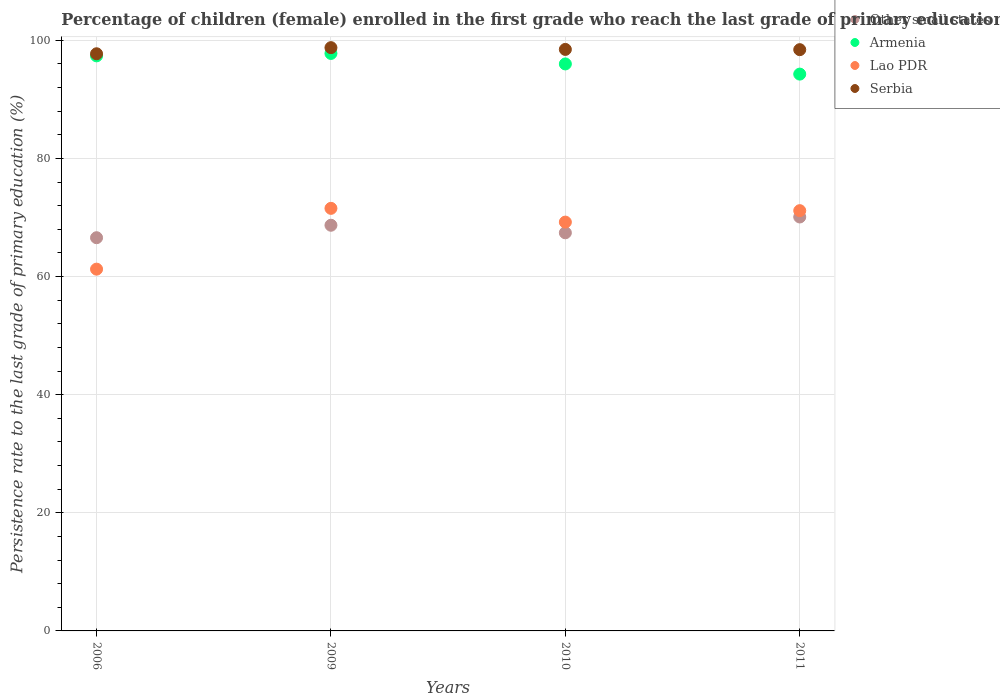What is the persistence rate of children in Lao PDR in 2010?
Ensure brevity in your answer.  69.21. Across all years, what is the maximum persistence rate of children in Serbia?
Offer a terse response. 98.75. Across all years, what is the minimum persistence rate of children in Armenia?
Ensure brevity in your answer.  94.27. In which year was the persistence rate of children in Other small states maximum?
Offer a terse response. 2011. What is the total persistence rate of children in Other small states in the graph?
Provide a short and direct response. 272.73. What is the difference between the persistence rate of children in Armenia in 2006 and that in 2009?
Offer a very short reply. -0.41. What is the difference between the persistence rate of children in Other small states in 2006 and the persistence rate of children in Armenia in 2011?
Your answer should be compact. -27.7. What is the average persistence rate of children in Lao PDR per year?
Your answer should be compact. 68.29. In the year 2009, what is the difference between the persistence rate of children in Serbia and persistence rate of children in Lao PDR?
Make the answer very short. 27.21. What is the ratio of the persistence rate of children in Lao PDR in 2006 to that in 2009?
Make the answer very short. 0.86. What is the difference between the highest and the second highest persistence rate of children in Armenia?
Your response must be concise. 0.41. What is the difference between the highest and the lowest persistence rate of children in Serbia?
Keep it short and to the point. 1.04. In how many years, is the persistence rate of children in Armenia greater than the average persistence rate of children in Armenia taken over all years?
Offer a terse response. 2. Does the persistence rate of children in Other small states monotonically increase over the years?
Offer a terse response. No. Is the persistence rate of children in Armenia strictly greater than the persistence rate of children in Lao PDR over the years?
Your answer should be compact. Yes. Is the persistence rate of children in Lao PDR strictly less than the persistence rate of children in Armenia over the years?
Offer a very short reply. Yes. What is the difference between two consecutive major ticks on the Y-axis?
Keep it short and to the point. 20. Are the values on the major ticks of Y-axis written in scientific E-notation?
Give a very brief answer. No. Does the graph contain any zero values?
Your response must be concise. No. Does the graph contain grids?
Ensure brevity in your answer.  Yes. Where does the legend appear in the graph?
Ensure brevity in your answer.  Top right. How are the legend labels stacked?
Keep it short and to the point. Vertical. What is the title of the graph?
Your answer should be compact. Percentage of children (female) enrolled in the first grade who reach the last grade of primary education. Does "Senegal" appear as one of the legend labels in the graph?
Your response must be concise. No. What is the label or title of the X-axis?
Give a very brief answer. Years. What is the label or title of the Y-axis?
Offer a very short reply. Persistence rate to the last grade of primary education (%). What is the Persistence rate to the last grade of primary education (%) in Other small states in 2006?
Ensure brevity in your answer.  66.57. What is the Persistence rate to the last grade of primary education (%) in Armenia in 2006?
Your answer should be compact. 97.36. What is the Persistence rate to the last grade of primary education (%) in Lao PDR in 2006?
Provide a succinct answer. 61.25. What is the Persistence rate to the last grade of primary education (%) in Serbia in 2006?
Offer a very short reply. 97.71. What is the Persistence rate to the last grade of primary education (%) in Other small states in 2009?
Make the answer very short. 68.68. What is the Persistence rate to the last grade of primary education (%) in Armenia in 2009?
Give a very brief answer. 97.76. What is the Persistence rate to the last grade of primary education (%) in Lao PDR in 2009?
Offer a very short reply. 71.54. What is the Persistence rate to the last grade of primary education (%) of Serbia in 2009?
Ensure brevity in your answer.  98.75. What is the Persistence rate to the last grade of primary education (%) of Other small states in 2010?
Offer a terse response. 67.4. What is the Persistence rate to the last grade of primary education (%) of Armenia in 2010?
Ensure brevity in your answer.  95.99. What is the Persistence rate to the last grade of primary education (%) of Lao PDR in 2010?
Your response must be concise. 69.21. What is the Persistence rate to the last grade of primary education (%) of Serbia in 2010?
Make the answer very short. 98.45. What is the Persistence rate to the last grade of primary education (%) of Other small states in 2011?
Ensure brevity in your answer.  70.08. What is the Persistence rate to the last grade of primary education (%) of Armenia in 2011?
Provide a short and direct response. 94.27. What is the Persistence rate to the last grade of primary education (%) in Lao PDR in 2011?
Your answer should be compact. 71.15. What is the Persistence rate to the last grade of primary education (%) of Serbia in 2011?
Offer a terse response. 98.41. Across all years, what is the maximum Persistence rate to the last grade of primary education (%) in Other small states?
Provide a succinct answer. 70.08. Across all years, what is the maximum Persistence rate to the last grade of primary education (%) of Armenia?
Your answer should be very brief. 97.76. Across all years, what is the maximum Persistence rate to the last grade of primary education (%) of Lao PDR?
Offer a very short reply. 71.54. Across all years, what is the maximum Persistence rate to the last grade of primary education (%) of Serbia?
Offer a very short reply. 98.75. Across all years, what is the minimum Persistence rate to the last grade of primary education (%) in Other small states?
Offer a terse response. 66.57. Across all years, what is the minimum Persistence rate to the last grade of primary education (%) in Armenia?
Provide a succinct answer. 94.27. Across all years, what is the minimum Persistence rate to the last grade of primary education (%) of Lao PDR?
Make the answer very short. 61.25. Across all years, what is the minimum Persistence rate to the last grade of primary education (%) of Serbia?
Your response must be concise. 97.71. What is the total Persistence rate to the last grade of primary education (%) in Other small states in the graph?
Keep it short and to the point. 272.73. What is the total Persistence rate to the last grade of primary education (%) in Armenia in the graph?
Provide a short and direct response. 385.37. What is the total Persistence rate to the last grade of primary education (%) in Lao PDR in the graph?
Your response must be concise. 273.15. What is the total Persistence rate to the last grade of primary education (%) of Serbia in the graph?
Ensure brevity in your answer.  393.31. What is the difference between the Persistence rate to the last grade of primary education (%) in Other small states in 2006 and that in 2009?
Make the answer very short. -2.11. What is the difference between the Persistence rate to the last grade of primary education (%) in Armenia in 2006 and that in 2009?
Your answer should be compact. -0.41. What is the difference between the Persistence rate to the last grade of primary education (%) in Lao PDR in 2006 and that in 2009?
Make the answer very short. -10.29. What is the difference between the Persistence rate to the last grade of primary education (%) in Serbia in 2006 and that in 2009?
Provide a short and direct response. -1.04. What is the difference between the Persistence rate to the last grade of primary education (%) of Other small states in 2006 and that in 2010?
Offer a very short reply. -0.83. What is the difference between the Persistence rate to the last grade of primary education (%) in Armenia in 2006 and that in 2010?
Keep it short and to the point. 1.37. What is the difference between the Persistence rate to the last grade of primary education (%) of Lao PDR in 2006 and that in 2010?
Provide a succinct answer. -7.97. What is the difference between the Persistence rate to the last grade of primary education (%) of Serbia in 2006 and that in 2010?
Keep it short and to the point. -0.74. What is the difference between the Persistence rate to the last grade of primary education (%) in Other small states in 2006 and that in 2011?
Ensure brevity in your answer.  -3.51. What is the difference between the Persistence rate to the last grade of primary education (%) of Armenia in 2006 and that in 2011?
Keep it short and to the point. 3.09. What is the difference between the Persistence rate to the last grade of primary education (%) in Lao PDR in 2006 and that in 2011?
Give a very brief answer. -9.9. What is the difference between the Persistence rate to the last grade of primary education (%) of Serbia in 2006 and that in 2011?
Your response must be concise. -0.7. What is the difference between the Persistence rate to the last grade of primary education (%) of Other small states in 2009 and that in 2010?
Your answer should be compact. 1.28. What is the difference between the Persistence rate to the last grade of primary education (%) of Armenia in 2009 and that in 2010?
Your answer should be very brief. 1.77. What is the difference between the Persistence rate to the last grade of primary education (%) of Lao PDR in 2009 and that in 2010?
Your answer should be compact. 2.33. What is the difference between the Persistence rate to the last grade of primary education (%) in Serbia in 2009 and that in 2010?
Ensure brevity in your answer.  0.3. What is the difference between the Persistence rate to the last grade of primary education (%) of Other small states in 2009 and that in 2011?
Your answer should be compact. -1.4. What is the difference between the Persistence rate to the last grade of primary education (%) of Armenia in 2009 and that in 2011?
Offer a very short reply. 3.5. What is the difference between the Persistence rate to the last grade of primary education (%) of Lao PDR in 2009 and that in 2011?
Offer a very short reply. 0.39. What is the difference between the Persistence rate to the last grade of primary education (%) of Serbia in 2009 and that in 2011?
Make the answer very short. 0.34. What is the difference between the Persistence rate to the last grade of primary education (%) of Other small states in 2010 and that in 2011?
Offer a very short reply. -2.68. What is the difference between the Persistence rate to the last grade of primary education (%) in Armenia in 2010 and that in 2011?
Your answer should be compact. 1.72. What is the difference between the Persistence rate to the last grade of primary education (%) of Lao PDR in 2010 and that in 2011?
Your response must be concise. -1.94. What is the difference between the Persistence rate to the last grade of primary education (%) in Serbia in 2010 and that in 2011?
Make the answer very short. 0.04. What is the difference between the Persistence rate to the last grade of primary education (%) in Other small states in 2006 and the Persistence rate to the last grade of primary education (%) in Armenia in 2009?
Give a very brief answer. -31.19. What is the difference between the Persistence rate to the last grade of primary education (%) in Other small states in 2006 and the Persistence rate to the last grade of primary education (%) in Lao PDR in 2009?
Provide a succinct answer. -4.97. What is the difference between the Persistence rate to the last grade of primary education (%) in Other small states in 2006 and the Persistence rate to the last grade of primary education (%) in Serbia in 2009?
Ensure brevity in your answer.  -32.18. What is the difference between the Persistence rate to the last grade of primary education (%) of Armenia in 2006 and the Persistence rate to the last grade of primary education (%) of Lao PDR in 2009?
Ensure brevity in your answer.  25.82. What is the difference between the Persistence rate to the last grade of primary education (%) in Armenia in 2006 and the Persistence rate to the last grade of primary education (%) in Serbia in 2009?
Offer a very short reply. -1.39. What is the difference between the Persistence rate to the last grade of primary education (%) of Lao PDR in 2006 and the Persistence rate to the last grade of primary education (%) of Serbia in 2009?
Keep it short and to the point. -37.5. What is the difference between the Persistence rate to the last grade of primary education (%) of Other small states in 2006 and the Persistence rate to the last grade of primary education (%) of Armenia in 2010?
Ensure brevity in your answer.  -29.42. What is the difference between the Persistence rate to the last grade of primary education (%) in Other small states in 2006 and the Persistence rate to the last grade of primary education (%) in Lao PDR in 2010?
Provide a short and direct response. -2.64. What is the difference between the Persistence rate to the last grade of primary education (%) in Other small states in 2006 and the Persistence rate to the last grade of primary education (%) in Serbia in 2010?
Offer a terse response. -31.88. What is the difference between the Persistence rate to the last grade of primary education (%) in Armenia in 2006 and the Persistence rate to the last grade of primary education (%) in Lao PDR in 2010?
Make the answer very short. 28.14. What is the difference between the Persistence rate to the last grade of primary education (%) of Armenia in 2006 and the Persistence rate to the last grade of primary education (%) of Serbia in 2010?
Provide a succinct answer. -1.09. What is the difference between the Persistence rate to the last grade of primary education (%) in Lao PDR in 2006 and the Persistence rate to the last grade of primary education (%) in Serbia in 2010?
Offer a terse response. -37.2. What is the difference between the Persistence rate to the last grade of primary education (%) of Other small states in 2006 and the Persistence rate to the last grade of primary education (%) of Armenia in 2011?
Keep it short and to the point. -27.7. What is the difference between the Persistence rate to the last grade of primary education (%) in Other small states in 2006 and the Persistence rate to the last grade of primary education (%) in Lao PDR in 2011?
Your response must be concise. -4.58. What is the difference between the Persistence rate to the last grade of primary education (%) of Other small states in 2006 and the Persistence rate to the last grade of primary education (%) of Serbia in 2011?
Offer a terse response. -31.84. What is the difference between the Persistence rate to the last grade of primary education (%) of Armenia in 2006 and the Persistence rate to the last grade of primary education (%) of Lao PDR in 2011?
Make the answer very short. 26.21. What is the difference between the Persistence rate to the last grade of primary education (%) of Armenia in 2006 and the Persistence rate to the last grade of primary education (%) of Serbia in 2011?
Offer a terse response. -1.05. What is the difference between the Persistence rate to the last grade of primary education (%) of Lao PDR in 2006 and the Persistence rate to the last grade of primary education (%) of Serbia in 2011?
Your response must be concise. -37.16. What is the difference between the Persistence rate to the last grade of primary education (%) of Other small states in 2009 and the Persistence rate to the last grade of primary education (%) of Armenia in 2010?
Provide a succinct answer. -27.31. What is the difference between the Persistence rate to the last grade of primary education (%) in Other small states in 2009 and the Persistence rate to the last grade of primary education (%) in Lao PDR in 2010?
Make the answer very short. -0.53. What is the difference between the Persistence rate to the last grade of primary education (%) in Other small states in 2009 and the Persistence rate to the last grade of primary education (%) in Serbia in 2010?
Offer a terse response. -29.77. What is the difference between the Persistence rate to the last grade of primary education (%) in Armenia in 2009 and the Persistence rate to the last grade of primary education (%) in Lao PDR in 2010?
Your answer should be compact. 28.55. What is the difference between the Persistence rate to the last grade of primary education (%) in Armenia in 2009 and the Persistence rate to the last grade of primary education (%) in Serbia in 2010?
Offer a very short reply. -0.68. What is the difference between the Persistence rate to the last grade of primary education (%) in Lao PDR in 2009 and the Persistence rate to the last grade of primary education (%) in Serbia in 2010?
Offer a very short reply. -26.91. What is the difference between the Persistence rate to the last grade of primary education (%) in Other small states in 2009 and the Persistence rate to the last grade of primary education (%) in Armenia in 2011?
Your answer should be compact. -25.59. What is the difference between the Persistence rate to the last grade of primary education (%) in Other small states in 2009 and the Persistence rate to the last grade of primary education (%) in Lao PDR in 2011?
Your response must be concise. -2.47. What is the difference between the Persistence rate to the last grade of primary education (%) in Other small states in 2009 and the Persistence rate to the last grade of primary education (%) in Serbia in 2011?
Give a very brief answer. -29.73. What is the difference between the Persistence rate to the last grade of primary education (%) in Armenia in 2009 and the Persistence rate to the last grade of primary education (%) in Lao PDR in 2011?
Keep it short and to the point. 26.61. What is the difference between the Persistence rate to the last grade of primary education (%) of Armenia in 2009 and the Persistence rate to the last grade of primary education (%) of Serbia in 2011?
Keep it short and to the point. -0.64. What is the difference between the Persistence rate to the last grade of primary education (%) in Lao PDR in 2009 and the Persistence rate to the last grade of primary education (%) in Serbia in 2011?
Make the answer very short. -26.87. What is the difference between the Persistence rate to the last grade of primary education (%) of Other small states in 2010 and the Persistence rate to the last grade of primary education (%) of Armenia in 2011?
Give a very brief answer. -26.86. What is the difference between the Persistence rate to the last grade of primary education (%) of Other small states in 2010 and the Persistence rate to the last grade of primary education (%) of Lao PDR in 2011?
Make the answer very short. -3.75. What is the difference between the Persistence rate to the last grade of primary education (%) of Other small states in 2010 and the Persistence rate to the last grade of primary education (%) of Serbia in 2011?
Keep it short and to the point. -31. What is the difference between the Persistence rate to the last grade of primary education (%) of Armenia in 2010 and the Persistence rate to the last grade of primary education (%) of Lao PDR in 2011?
Make the answer very short. 24.84. What is the difference between the Persistence rate to the last grade of primary education (%) of Armenia in 2010 and the Persistence rate to the last grade of primary education (%) of Serbia in 2011?
Give a very brief answer. -2.42. What is the difference between the Persistence rate to the last grade of primary education (%) of Lao PDR in 2010 and the Persistence rate to the last grade of primary education (%) of Serbia in 2011?
Make the answer very short. -29.19. What is the average Persistence rate to the last grade of primary education (%) of Other small states per year?
Provide a succinct answer. 68.18. What is the average Persistence rate to the last grade of primary education (%) of Armenia per year?
Your answer should be very brief. 96.34. What is the average Persistence rate to the last grade of primary education (%) in Lao PDR per year?
Your response must be concise. 68.29. What is the average Persistence rate to the last grade of primary education (%) in Serbia per year?
Offer a very short reply. 98.33. In the year 2006, what is the difference between the Persistence rate to the last grade of primary education (%) of Other small states and Persistence rate to the last grade of primary education (%) of Armenia?
Your response must be concise. -30.79. In the year 2006, what is the difference between the Persistence rate to the last grade of primary education (%) of Other small states and Persistence rate to the last grade of primary education (%) of Lao PDR?
Make the answer very short. 5.32. In the year 2006, what is the difference between the Persistence rate to the last grade of primary education (%) of Other small states and Persistence rate to the last grade of primary education (%) of Serbia?
Your answer should be very brief. -31.14. In the year 2006, what is the difference between the Persistence rate to the last grade of primary education (%) in Armenia and Persistence rate to the last grade of primary education (%) in Lao PDR?
Provide a succinct answer. 36.11. In the year 2006, what is the difference between the Persistence rate to the last grade of primary education (%) in Armenia and Persistence rate to the last grade of primary education (%) in Serbia?
Provide a succinct answer. -0.35. In the year 2006, what is the difference between the Persistence rate to the last grade of primary education (%) of Lao PDR and Persistence rate to the last grade of primary education (%) of Serbia?
Ensure brevity in your answer.  -36.46. In the year 2009, what is the difference between the Persistence rate to the last grade of primary education (%) of Other small states and Persistence rate to the last grade of primary education (%) of Armenia?
Your answer should be very brief. -29.08. In the year 2009, what is the difference between the Persistence rate to the last grade of primary education (%) in Other small states and Persistence rate to the last grade of primary education (%) in Lao PDR?
Provide a short and direct response. -2.86. In the year 2009, what is the difference between the Persistence rate to the last grade of primary education (%) in Other small states and Persistence rate to the last grade of primary education (%) in Serbia?
Offer a very short reply. -30.07. In the year 2009, what is the difference between the Persistence rate to the last grade of primary education (%) of Armenia and Persistence rate to the last grade of primary education (%) of Lao PDR?
Offer a very short reply. 26.22. In the year 2009, what is the difference between the Persistence rate to the last grade of primary education (%) of Armenia and Persistence rate to the last grade of primary education (%) of Serbia?
Your answer should be very brief. -0.98. In the year 2009, what is the difference between the Persistence rate to the last grade of primary education (%) of Lao PDR and Persistence rate to the last grade of primary education (%) of Serbia?
Your response must be concise. -27.21. In the year 2010, what is the difference between the Persistence rate to the last grade of primary education (%) in Other small states and Persistence rate to the last grade of primary education (%) in Armenia?
Provide a succinct answer. -28.59. In the year 2010, what is the difference between the Persistence rate to the last grade of primary education (%) in Other small states and Persistence rate to the last grade of primary education (%) in Lao PDR?
Ensure brevity in your answer.  -1.81. In the year 2010, what is the difference between the Persistence rate to the last grade of primary education (%) of Other small states and Persistence rate to the last grade of primary education (%) of Serbia?
Provide a succinct answer. -31.05. In the year 2010, what is the difference between the Persistence rate to the last grade of primary education (%) in Armenia and Persistence rate to the last grade of primary education (%) in Lao PDR?
Make the answer very short. 26.78. In the year 2010, what is the difference between the Persistence rate to the last grade of primary education (%) in Armenia and Persistence rate to the last grade of primary education (%) in Serbia?
Ensure brevity in your answer.  -2.46. In the year 2010, what is the difference between the Persistence rate to the last grade of primary education (%) of Lao PDR and Persistence rate to the last grade of primary education (%) of Serbia?
Provide a short and direct response. -29.23. In the year 2011, what is the difference between the Persistence rate to the last grade of primary education (%) of Other small states and Persistence rate to the last grade of primary education (%) of Armenia?
Make the answer very short. -24.19. In the year 2011, what is the difference between the Persistence rate to the last grade of primary education (%) in Other small states and Persistence rate to the last grade of primary education (%) in Lao PDR?
Give a very brief answer. -1.07. In the year 2011, what is the difference between the Persistence rate to the last grade of primary education (%) of Other small states and Persistence rate to the last grade of primary education (%) of Serbia?
Your answer should be compact. -28.33. In the year 2011, what is the difference between the Persistence rate to the last grade of primary education (%) of Armenia and Persistence rate to the last grade of primary education (%) of Lao PDR?
Provide a short and direct response. 23.12. In the year 2011, what is the difference between the Persistence rate to the last grade of primary education (%) in Armenia and Persistence rate to the last grade of primary education (%) in Serbia?
Your response must be concise. -4.14. In the year 2011, what is the difference between the Persistence rate to the last grade of primary education (%) of Lao PDR and Persistence rate to the last grade of primary education (%) of Serbia?
Offer a terse response. -27.26. What is the ratio of the Persistence rate to the last grade of primary education (%) in Other small states in 2006 to that in 2009?
Offer a terse response. 0.97. What is the ratio of the Persistence rate to the last grade of primary education (%) in Lao PDR in 2006 to that in 2009?
Offer a terse response. 0.86. What is the ratio of the Persistence rate to the last grade of primary education (%) in Serbia in 2006 to that in 2009?
Provide a succinct answer. 0.99. What is the ratio of the Persistence rate to the last grade of primary education (%) in Other small states in 2006 to that in 2010?
Make the answer very short. 0.99. What is the ratio of the Persistence rate to the last grade of primary education (%) of Armenia in 2006 to that in 2010?
Your answer should be compact. 1.01. What is the ratio of the Persistence rate to the last grade of primary education (%) of Lao PDR in 2006 to that in 2010?
Offer a very short reply. 0.88. What is the ratio of the Persistence rate to the last grade of primary education (%) in Other small states in 2006 to that in 2011?
Keep it short and to the point. 0.95. What is the ratio of the Persistence rate to the last grade of primary education (%) of Armenia in 2006 to that in 2011?
Offer a terse response. 1.03. What is the ratio of the Persistence rate to the last grade of primary education (%) in Lao PDR in 2006 to that in 2011?
Ensure brevity in your answer.  0.86. What is the ratio of the Persistence rate to the last grade of primary education (%) of Serbia in 2006 to that in 2011?
Offer a very short reply. 0.99. What is the ratio of the Persistence rate to the last grade of primary education (%) in Other small states in 2009 to that in 2010?
Offer a very short reply. 1.02. What is the ratio of the Persistence rate to the last grade of primary education (%) in Armenia in 2009 to that in 2010?
Ensure brevity in your answer.  1.02. What is the ratio of the Persistence rate to the last grade of primary education (%) in Lao PDR in 2009 to that in 2010?
Your answer should be very brief. 1.03. What is the ratio of the Persistence rate to the last grade of primary education (%) in Serbia in 2009 to that in 2010?
Ensure brevity in your answer.  1. What is the ratio of the Persistence rate to the last grade of primary education (%) in Other small states in 2009 to that in 2011?
Your answer should be compact. 0.98. What is the ratio of the Persistence rate to the last grade of primary education (%) of Armenia in 2009 to that in 2011?
Offer a very short reply. 1.04. What is the ratio of the Persistence rate to the last grade of primary education (%) of Lao PDR in 2009 to that in 2011?
Offer a very short reply. 1.01. What is the ratio of the Persistence rate to the last grade of primary education (%) in Other small states in 2010 to that in 2011?
Give a very brief answer. 0.96. What is the ratio of the Persistence rate to the last grade of primary education (%) in Armenia in 2010 to that in 2011?
Offer a terse response. 1.02. What is the ratio of the Persistence rate to the last grade of primary education (%) in Lao PDR in 2010 to that in 2011?
Offer a terse response. 0.97. What is the difference between the highest and the second highest Persistence rate to the last grade of primary education (%) of Other small states?
Offer a terse response. 1.4. What is the difference between the highest and the second highest Persistence rate to the last grade of primary education (%) of Armenia?
Your answer should be very brief. 0.41. What is the difference between the highest and the second highest Persistence rate to the last grade of primary education (%) in Lao PDR?
Provide a short and direct response. 0.39. What is the difference between the highest and the second highest Persistence rate to the last grade of primary education (%) of Serbia?
Your answer should be very brief. 0.3. What is the difference between the highest and the lowest Persistence rate to the last grade of primary education (%) of Other small states?
Offer a terse response. 3.51. What is the difference between the highest and the lowest Persistence rate to the last grade of primary education (%) of Armenia?
Give a very brief answer. 3.5. What is the difference between the highest and the lowest Persistence rate to the last grade of primary education (%) of Lao PDR?
Your answer should be compact. 10.29. 